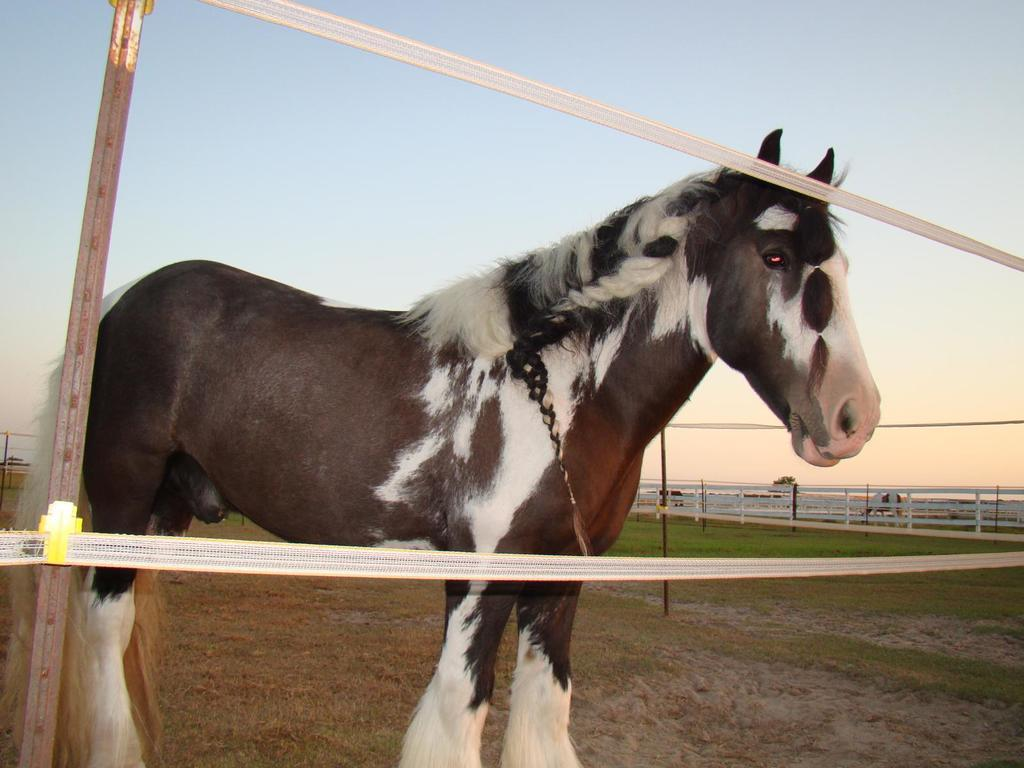What animal is present in the image? There is a horse in the image. What colors can be seen on the horse? The horse has black, brown, and white colors. What type of barrier is visible in the image? There is fencing in the image. What type of vegetation is present in the image? There is grass in the image. What is the color of the sky in the image? The sky is blue and white in color. What is the purpose of the comb in the image? There is no comb present in the image. 